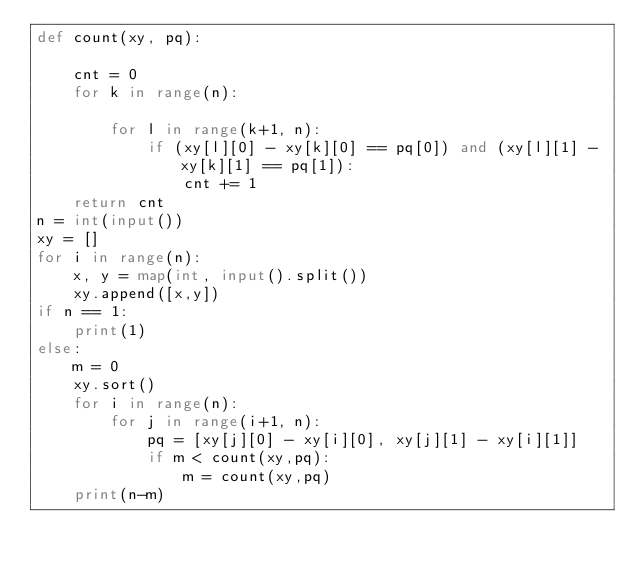<code> <loc_0><loc_0><loc_500><loc_500><_Python_>def count(xy, pq):

    cnt = 0
    for k in range(n):
        
        for l in range(k+1, n):
            if (xy[l][0] - xy[k][0] == pq[0]) and (xy[l][1] - xy[k][1] == pq[1]):
                cnt += 1
    return cnt
n = int(input())
xy = []
for i in range(n):
    x, y = map(int, input().split())
    xy.append([x,y])
if n == 1:
    print(1)
else:
    m = 0
    xy.sort()
    for i in range(n):
        for j in range(i+1, n):
            pq = [xy[j][0] - xy[i][0], xy[j][1] - xy[i][1]]
            if m < count(xy,pq):
                m = count(xy,pq)
    print(n-m)</code> 